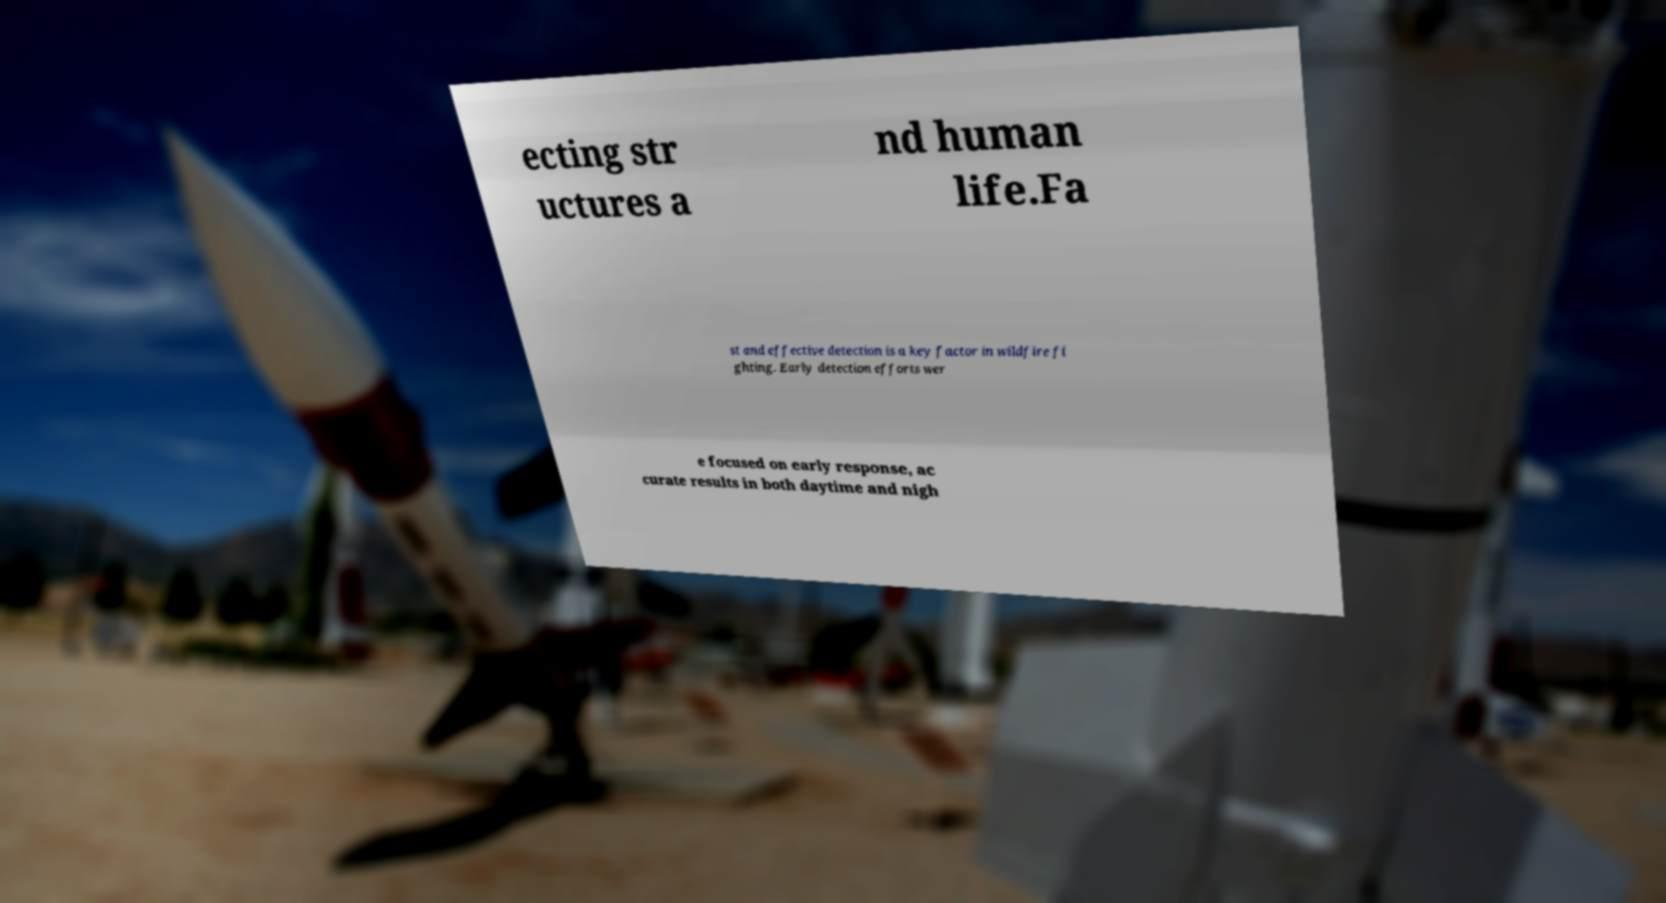I need the written content from this picture converted into text. Can you do that? ecting str uctures a nd human life.Fa st and effective detection is a key factor in wildfire fi ghting. Early detection efforts wer e focused on early response, ac curate results in both daytime and nigh 